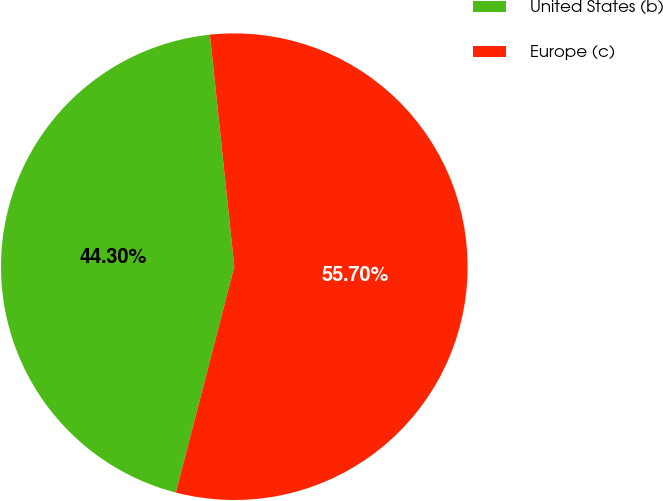<chart> <loc_0><loc_0><loc_500><loc_500><pie_chart><fcel>United States (b)<fcel>Europe (c)<nl><fcel>44.3%<fcel>55.7%<nl></chart> 